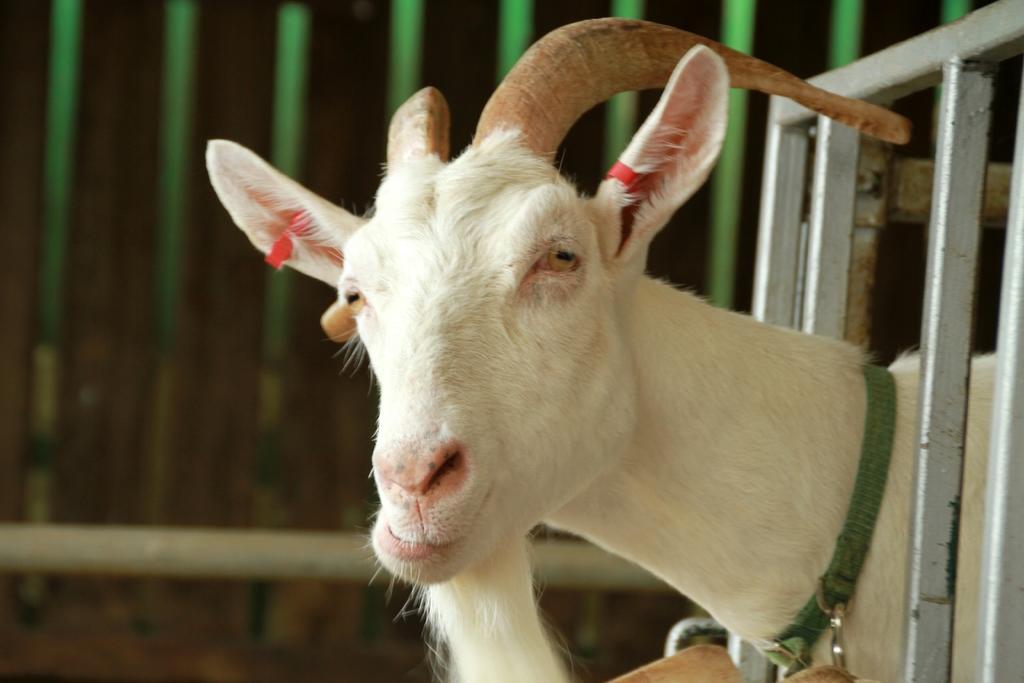In one or two sentences, can you explain what this image depicts? In this image we can see an animal and rods. There is a blur background. 